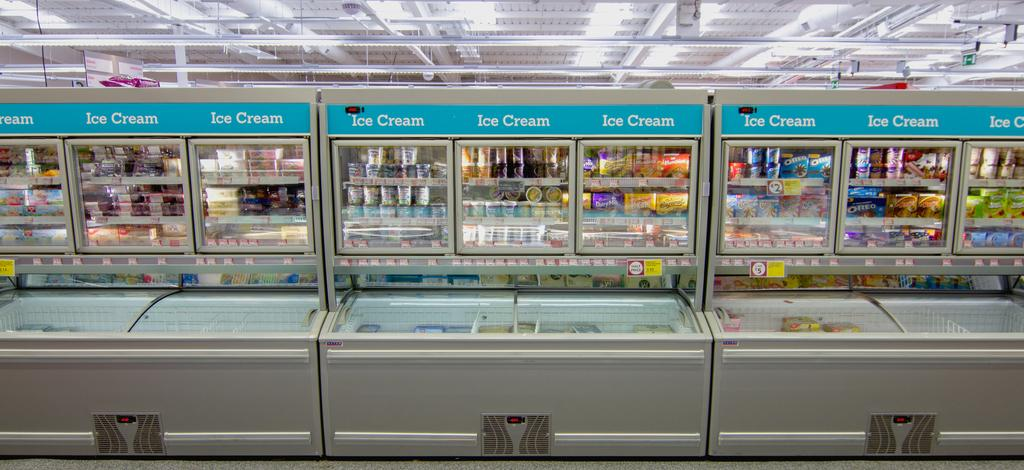<image>
Relay a brief, clear account of the picture shown. The freezer department of a store full of different ice cream options. 